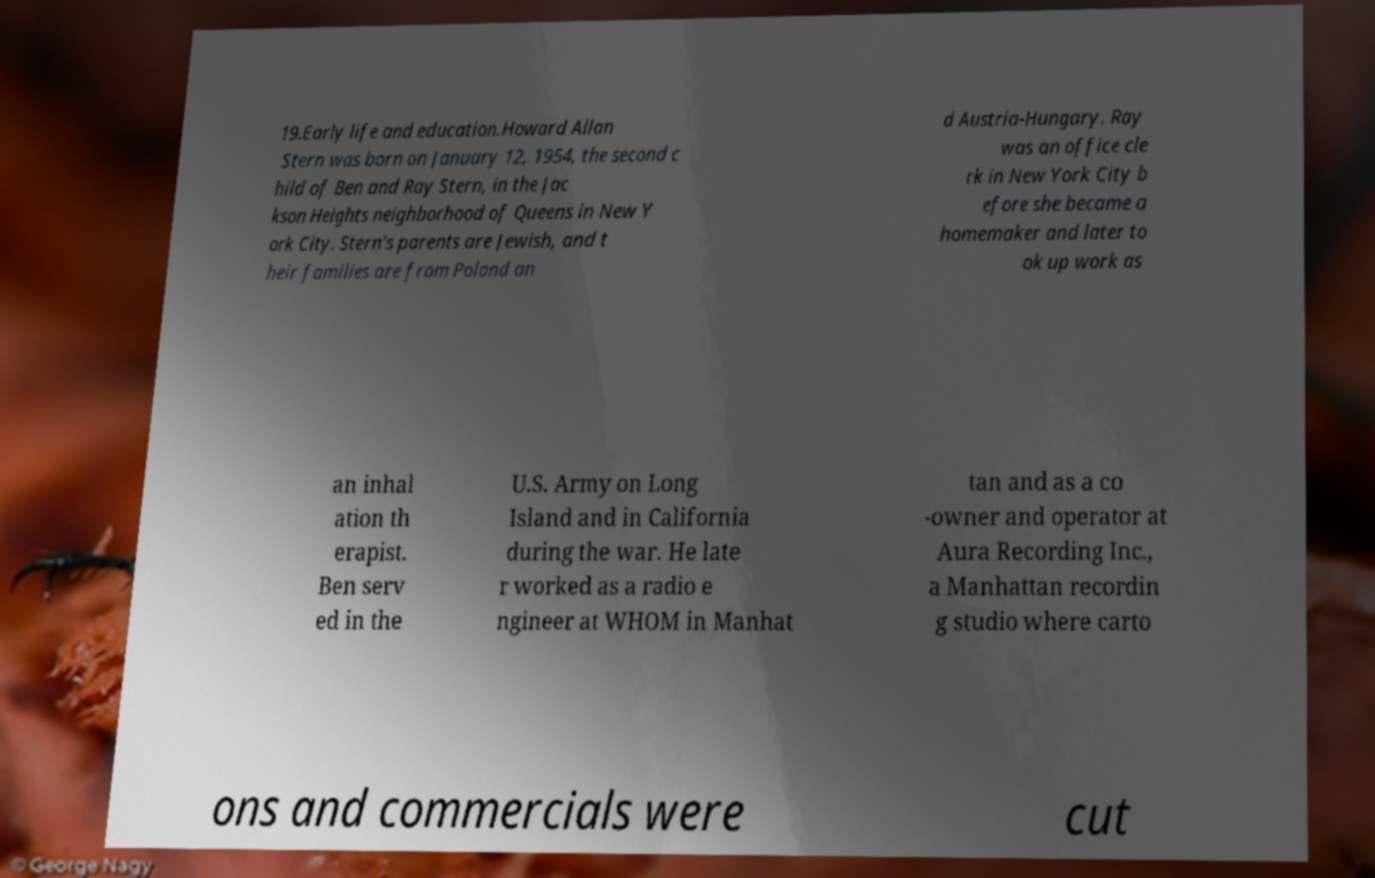For documentation purposes, I need the text within this image transcribed. Could you provide that? 19.Early life and education.Howard Allan Stern was born on January 12, 1954, the second c hild of Ben and Ray Stern, in the Jac kson Heights neighborhood of Queens in New Y ork City. Stern's parents are Jewish, and t heir families are from Poland an d Austria-Hungary. Ray was an office cle rk in New York City b efore she became a homemaker and later to ok up work as an inhal ation th erapist. Ben serv ed in the U.S. Army on Long Island and in California during the war. He late r worked as a radio e ngineer at WHOM in Manhat tan and as a co -owner and operator at Aura Recording Inc., a Manhattan recordin g studio where carto ons and commercials were cut 